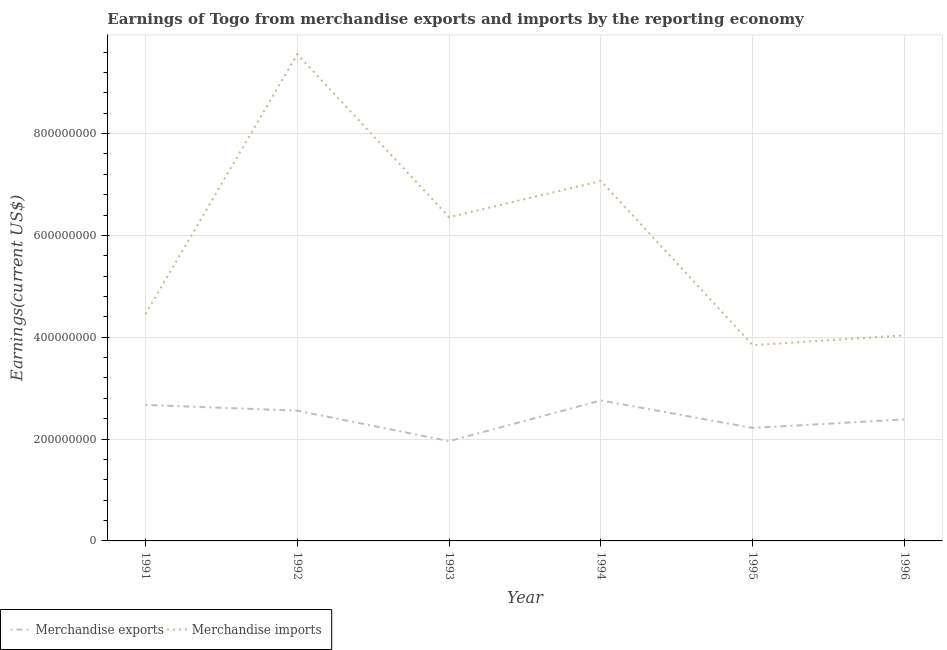Does the line corresponding to earnings from merchandise imports intersect with the line corresponding to earnings from merchandise exports?
Your answer should be very brief. No. Is the number of lines equal to the number of legend labels?
Your answer should be very brief. Yes. What is the earnings from merchandise exports in 1993?
Offer a very short reply. 1.96e+08. Across all years, what is the maximum earnings from merchandise exports?
Ensure brevity in your answer.  2.76e+08. Across all years, what is the minimum earnings from merchandise exports?
Provide a succinct answer. 1.96e+08. What is the total earnings from merchandise imports in the graph?
Your answer should be compact. 3.53e+09. What is the difference between the earnings from merchandise imports in 1994 and that in 1995?
Your answer should be compact. 3.23e+08. What is the difference between the earnings from merchandise imports in 1993 and the earnings from merchandise exports in 1992?
Ensure brevity in your answer.  3.80e+08. What is the average earnings from merchandise exports per year?
Ensure brevity in your answer.  2.43e+08. In the year 1996, what is the difference between the earnings from merchandise imports and earnings from merchandise exports?
Provide a succinct answer. 1.65e+08. In how many years, is the earnings from merchandise exports greater than 80000000 US$?
Keep it short and to the point. 6. What is the ratio of the earnings from merchandise imports in 1991 to that in 1993?
Offer a terse response. 0.7. Is the earnings from merchandise imports in 1993 less than that in 1995?
Offer a very short reply. No. What is the difference between the highest and the second highest earnings from merchandise imports?
Your response must be concise. 2.49e+08. What is the difference between the highest and the lowest earnings from merchandise imports?
Your answer should be compact. 5.71e+08. In how many years, is the earnings from merchandise exports greater than the average earnings from merchandise exports taken over all years?
Your response must be concise. 3. Is the sum of the earnings from merchandise imports in 1995 and 1996 greater than the maximum earnings from merchandise exports across all years?
Keep it short and to the point. Yes. How many lines are there?
Provide a succinct answer. 2. How many years are there in the graph?
Give a very brief answer. 6. Does the graph contain any zero values?
Provide a short and direct response. No. Where does the legend appear in the graph?
Make the answer very short. Bottom left. How many legend labels are there?
Provide a short and direct response. 2. How are the legend labels stacked?
Give a very brief answer. Horizontal. What is the title of the graph?
Your answer should be compact. Earnings of Togo from merchandise exports and imports by the reporting economy. What is the label or title of the X-axis?
Make the answer very short. Year. What is the label or title of the Y-axis?
Provide a short and direct response. Earnings(current US$). What is the Earnings(current US$) of Merchandise exports in 1991?
Your answer should be very brief. 2.67e+08. What is the Earnings(current US$) of Merchandise imports in 1991?
Offer a terse response. 4.45e+08. What is the Earnings(current US$) of Merchandise exports in 1992?
Keep it short and to the point. 2.56e+08. What is the Earnings(current US$) in Merchandise imports in 1992?
Keep it short and to the point. 9.56e+08. What is the Earnings(current US$) in Merchandise exports in 1993?
Offer a very short reply. 1.96e+08. What is the Earnings(current US$) in Merchandise imports in 1993?
Provide a succinct answer. 6.36e+08. What is the Earnings(current US$) in Merchandise exports in 1994?
Your answer should be compact. 2.76e+08. What is the Earnings(current US$) of Merchandise imports in 1994?
Provide a short and direct response. 7.07e+08. What is the Earnings(current US$) in Merchandise exports in 1995?
Your answer should be very brief. 2.22e+08. What is the Earnings(current US$) in Merchandise imports in 1995?
Give a very brief answer. 3.84e+08. What is the Earnings(current US$) in Merchandise exports in 1996?
Your answer should be compact. 2.39e+08. What is the Earnings(current US$) in Merchandise imports in 1996?
Keep it short and to the point. 4.04e+08. Across all years, what is the maximum Earnings(current US$) in Merchandise exports?
Offer a terse response. 2.76e+08. Across all years, what is the maximum Earnings(current US$) in Merchandise imports?
Keep it short and to the point. 9.56e+08. Across all years, what is the minimum Earnings(current US$) in Merchandise exports?
Your answer should be very brief. 1.96e+08. Across all years, what is the minimum Earnings(current US$) of Merchandise imports?
Provide a short and direct response. 3.84e+08. What is the total Earnings(current US$) of Merchandise exports in the graph?
Offer a very short reply. 1.46e+09. What is the total Earnings(current US$) in Merchandise imports in the graph?
Offer a terse response. 3.53e+09. What is the difference between the Earnings(current US$) of Merchandise exports in 1991 and that in 1992?
Make the answer very short. 1.12e+07. What is the difference between the Earnings(current US$) in Merchandise imports in 1991 and that in 1992?
Ensure brevity in your answer.  -5.10e+08. What is the difference between the Earnings(current US$) in Merchandise exports in 1991 and that in 1993?
Keep it short and to the point. 7.11e+07. What is the difference between the Earnings(current US$) of Merchandise imports in 1991 and that in 1993?
Make the answer very short. -1.90e+08. What is the difference between the Earnings(current US$) of Merchandise exports in 1991 and that in 1994?
Your response must be concise. -8.78e+06. What is the difference between the Earnings(current US$) of Merchandise imports in 1991 and that in 1994?
Offer a very short reply. -2.61e+08. What is the difference between the Earnings(current US$) of Merchandise exports in 1991 and that in 1995?
Provide a succinct answer. 4.52e+07. What is the difference between the Earnings(current US$) in Merchandise imports in 1991 and that in 1995?
Provide a short and direct response. 6.11e+07. What is the difference between the Earnings(current US$) in Merchandise exports in 1991 and that in 1996?
Offer a terse response. 2.84e+07. What is the difference between the Earnings(current US$) of Merchandise imports in 1991 and that in 1996?
Your answer should be compact. 4.16e+07. What is the difference between the Earnings(current US$) of Merchandise exports in 1992 and that in 1993?
Your answer should be compact. 5.99e+07. What is the difference between the Earnings(current US$) of Merchandise imports in 1992 and that in 1993?
Your response must be concise. 3.20e+08. What is the difference between the Earnings(current US$) in Merchandise exports in 1992 and that in 1994?
Your response must be concise. -2.00e+07. What is the difference between the Earnings(current US$) in Merchandise imports in 1992 and that in 1994?
Your response must be concise. 2.49e+08. What is the difference between the Earnings(current US$) in Merchandise exports in 1992 and that in 1995?
Keep it short and to the point. 3.40e+07. What is the difference between the Earnings(current US$) in Merchandise imports in 1992 and that in 1995?
Keep it short and to the point. 5.71e+08. What is the difference between the Earnings(current US$) in Merchandise exports in 1992 and that in 1996?
Make the answer very short. 1.71e+07. What is the difference between the Earnings(current US$) of Merchandise imports in 1992 and that in 1996?
Give a very brief answer. 5.52e+08. What is the difference between the Earnings(current US$) of Merchandise exports in 1993 and that in 1994?
Provide a succinct answer. -7.99e+07. What is the difference between the Earnings(current US$) of Merchandise imports in 1993 and that in 1994?
Offer a very short reply. -7.11e+07. What is the difference between the Earnings(current US$) in Merchandise exports in 1993 and that in 1995?
Offer a terse response. -2.59e+07. What is the difference between the Earnings(current US$) in Merchandise imports in 1993 and that in 1995?
Give a very brief answer. 2.51e+08. What is the difference between the Earnings(current US$) of Merchandise exports in 1993 and that in 1996?
Offer a very short reply. -4.27e+07. What is the difference between the Earnings(current US$) in Merchandise imports in 1993 and that in 1996?
Give a very brief answer. 2.32e+08. What is the difference between the Earnings(current US$) of Merchandise exports in 1994 and that in 1995?
Provide a short and direct response. 5.40e+07. What is the difference between the Earnings(current US$) of Merchandise imports in 1994 and that in 1995?
Your response must be concise. 3.23e+08. What is the difference between the Earnings(current US$) of Merchandise exports in 1994 and that in 1996?
Ensure brevity in your answer.  3.72e+07. What is the difference between the Earnings(current US$) of Merchandise imports in 1994 and that in 1996?
Give a very brief answer. 3.03e+08. What is the difference between the Earnings(current US$) in Merchandise exports in 1995 and that in 1996?
Offer a terse response. -1.68e+07. What is the difference between the Earnings(current US$) in Merchandise imports in 1995 and that in 1996?
Offer a very short reply. -1.95e+07. What is the difference between the Earnings(current US$) of Merchandise exports in 1991 and the Earnings(current US$) of Merchandise imports in 1992?
Your answer should be compact. -6.89e+08. What is the difference between the Earnings(current US$) in Merchandise exports in 1991 and the Earnings(current US$) in Merchandise imports in 1993?
Your answer should be very brief. -3.69e+08. What is the difference between the Earnings(current US$) of Merchandise exports in 1991 and the Earnings(current US$) of Merchandise imports in 1994?
Ensure brevity in your answer.  -4.40e+08. What is the difference between the Earnings(current US$) in Merchandise exports in 1991 and the Earnings(current US$) in Merchandise imports in 1995?
Offer a terse response. -1.17e+08. What is the difference between the Earnings(current US$) in Merchandise exports in 1991 and the Earnings(current US$) in Merchandise imports in 1996?
Your answer should be very brief. -1.37e+08. What is the difference between the Earnings(current US$) in Merchandise exports in 1992 and the Earnings(current US$) in Merchandise imports in 1993?
Provide a succinct answer. -3.80e+08. What is the difference between the Earnings(current US$) in Merchandise exports in 1992 and the Earnings(current US$) in Merchandise imports in 1994?
Provide a succinct answer. -4.51e+08. What is the difference between the Earnings(current US$) in Merchandise exports in 1992 and the Earnings(current US$) in Merchandise imports in 1995?
Offer a terse response. -1.28e+08. What is the difference between the Earnings(current US$) in Merchandise exports in 1992 and the Earnings(current US$) in Merchandise imports in 1996?
Give a very brief answer. -1.48e+08. What is the difference between the Earnings(current US$) in Merchandise exports in 1993 and the Earnings(current US$) in Merchandise imports in 1994?
Keep it short and to the point. -5.11e+08. What is the difference between the Earnings(current US$) of Merchandise exports in 1993 and the Earnings(current US$) of Merchandise imports in 1995?
Offer a terse response. -1.88e+08. What is the difference between the Earnings(current US$) in Merchandise exports in 1993 and the Earnings(current US$) in Merchandise imports in 1996?
Ensure brevity in your answer.  -2.08e+08. What is the difference between the Earnings(current US$) of Merchandise exports in 1994 and the Earnings(current US$) of Merchandise imports in 1995?
Provide a succinct answer. -1.08e+08. What is the difference between the Earnings(current US$) in Merchandise exports in 1994 and the Earnings(current US$) in Merchandise imports in 1996?
Offer a terse response. -1.28e+08. What is the difference between the Earnings(current US$) in Merchandise exports in 1995 and the Earnings(current US$) in Merchandise imports in 1996?
Make the answer very short. -1.82e+08. What is the average Earnings(current US$) in Merchandise exports per year?
Offer a terse response. 2.43e+08. What is the average Earnings(current US$) of Merchandise imports per year?
Offer a terse response. 5.89e+08. In the year 1991, what is the difference between the Earnings(current US$) in Merchandise exports and Earnings(current US$) in Merchandise imports?
Ensure brevity in your answer.  -1.78e+08. In the year 1992, what is the difference between the Earnings(current US$) in Merchandise exports and Earnings(current US$) in Merchandise imports?
Provide a succinct answer. -7.00e+08. In the year 1993, what is the difference between the Earnings(current US$) of Merchandise exports and Earnings(current US$) of Merchandise imports?
Your answer should be compact. -4.40e+08. In the year 1994, what is the difference between the Earnings(current US$) of Merchandise exports and Earnings(current US$) of Merchandise imports?
Give a very brief answer. -4.31e+08. In the year 1995, what is the difference between the Earnings(current US$) in Merchandise exports and Earnings(current US$) in Merchandise imports?
Give a very brief answer. -1.62e+08. In the year 1996, what is the difference between the Earnings(current US$) in Merchandise exports and Earnings(current US$) in Merchandise imports?
Give a very brief answer. -1.65e+08. What is the ratio of the Earnings(current US$) in Merchandise exports in 1991 to that in 1992?
Provide a succinct answer. 1.04. What is the ratio of the Earnings(current US$) in Merchandise imports in 1991 to that in 1992?
Provide a short and direct response. 0.47. What is the ratio of the Earnings(current US$) in Merchandise exports in 1991 to that in 1993?
Keep it short and to the point. 1.36. What is the ratio of the Earnings(current US$) in Merchandise imports in 1991 to that in 1993?
Your answer should be very brief. 0.7. What is the ratio of the Earnings(current US$) of Merchandise exports in 1991 to that in 1994?
Make the answer very short. 0.97. What is the ratio of the Earnings(current US$) in Merchandise imports in 1991 to that in 1994?
Your response must be concise. 0.63. What is the ratio of the Earnings(current US$) in Merchandise exports in 1991 to that in 1995?
Offer a very short reply. 1.2. What is the ratio of the Earnings(current US$) in Merchandise imports in 1991 to that in 1995?
Keep it short and to the point. 1.16. What is the ratio of the Earnings(current US$) of Merchandise exports in 1991 to that in 1996?
Make the answer very short. 1.12. What is the ratio of the Earnings(current US$) in Merchandise imports in 1991 to that in 1996?
Give a very brief answer. 1.1. What is the ratio of the Earnings(current US$) of Merchandise exports in 1992 to that in 1993?
Your answer should be very brief. 1.31. What is the ratio of the Earnings(current US$) of Merchandise imports in 1992 to that in 1993?
Your answer should be very brief. 1.5. What is the ratio of the Earnings(current US$) of Merchandise exports in 1992 to that in 1994?
Offer a very short reply. 0.93. What is the ratio of the Earnings(current US$) in Merchandise imports in 1992 to that in 1994?
Provide a succinct answer. 1.35. What is the ratio of the Earnings(current US$) in Merchandise exports in 1992 to that in 1995?
Offer a terse response. 1.15. What is the ratio of the Earnings(current US$) of Merchandise imports in 1992 to that in 1995?
Make the answer very short. 2.49. What is the ratio of the Earnings(current US$) in Merchandise exports in 1992 to that in 1996?
Your answer should be compact. 1.07. What is the ratio of the Earnings(current US$) in Merchandise imports in 1992 to that in 1996?
Ensure brevity in your answer.  2.37. What is the ratio of the Earnings(current US$) in Merchandise exports in 1993 to that in 1994?
Offer a terse response. 0.71. What is the ratio of the Earnings(current US$) of Merchandise imports in 1993 to that in 1994?
Your answer should be compact. 0.9. What is the ratio of the Earnings(current US$) of Merchandise exports in 1993 to that in 1995?
Provide a succinct answer. 0.88. What is the ratio of the Earnings(current US$) in Merchandise imports in 1993 to that in 1995?
Offer a terse response. 1.65. What is the ratio of the Earnings(current US$) of Merchandise exports in 1993 to that in 1996?
Make the answer very short. 0.82. What is the ratio of the Earnings(current US$) in Merchandise imports in 1993 to that in 1996?
Your answer should be compact. 1.57. What is the ratio of the Earnings(current US$) in Merchandise exports in 1994 to that in 1995?
Provide a short and direct response. 1.24. What is the ratio of the Earnings(current US$) in Merchandise imports in 1994 to that in 1995?
Provide a succinct answer. 1.84. What is the ratio of the Earnings(current US$) of Merchandise exports in 1994 to that in 1996?
Offer a very short reply. 1.16. What is the ratio of the Earnings(current US$) in Merchandise imports in 1994 to that in 1996?
Give a very brief answer. 1.75. What is the ratio of the Earnings(current US$) of Merchandise exports in 1995 to that in 1996?
Ensure brevity in your answer.  0.93. What is the ratio of the Earnings(current US$) in Merchandise imports in 1995 to that in 1996?
Your answer should be compact. 0.95. What is the difference between the highest and the second highest Earnings(current US$) in Merchandise exports?
Your answer should be very brief. 8.78e+06. What is the difference between the highest and the second highest Earnings(current US$) of Merchandise imports?
Your answer should be compact. 2.49e+08. What is the difference between the highest and the lowest Earnings(current US$) in Merchandise exports?
Give a very brief answer. 7.99e+07. What is the difference between the highest and the lowest Earnings(current US$) of Merchandise imports?
Provide a short and direct response. 5.71e+08. 